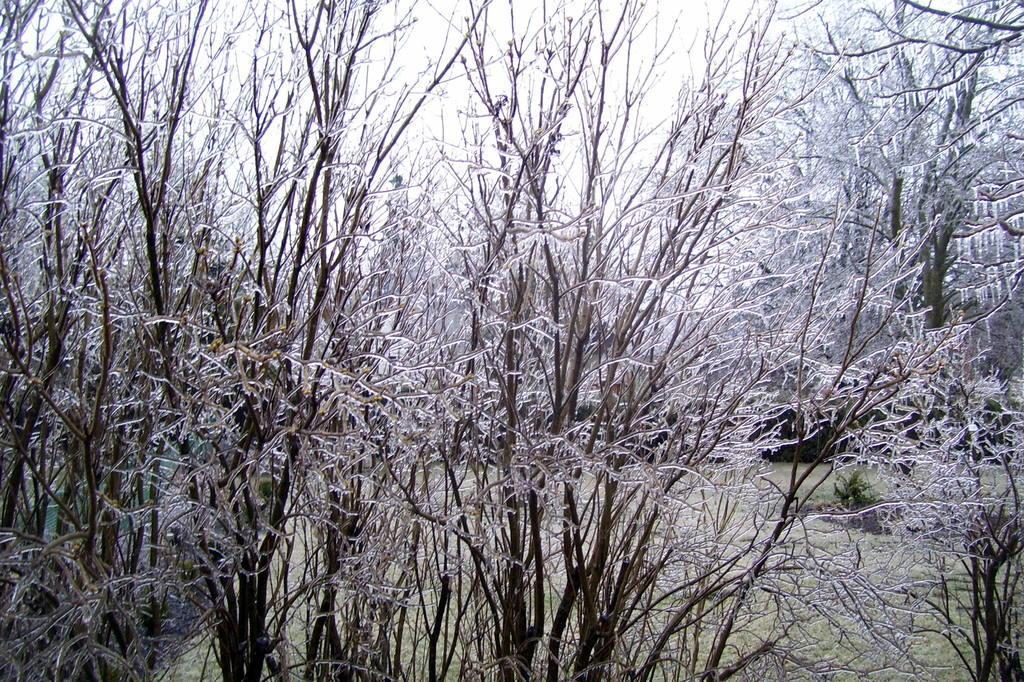Could you give a brief overview of what you see in this image? This picture is clicked outside. In the foreground we can see the trees. In the background we can see the plants, grass and sky. 